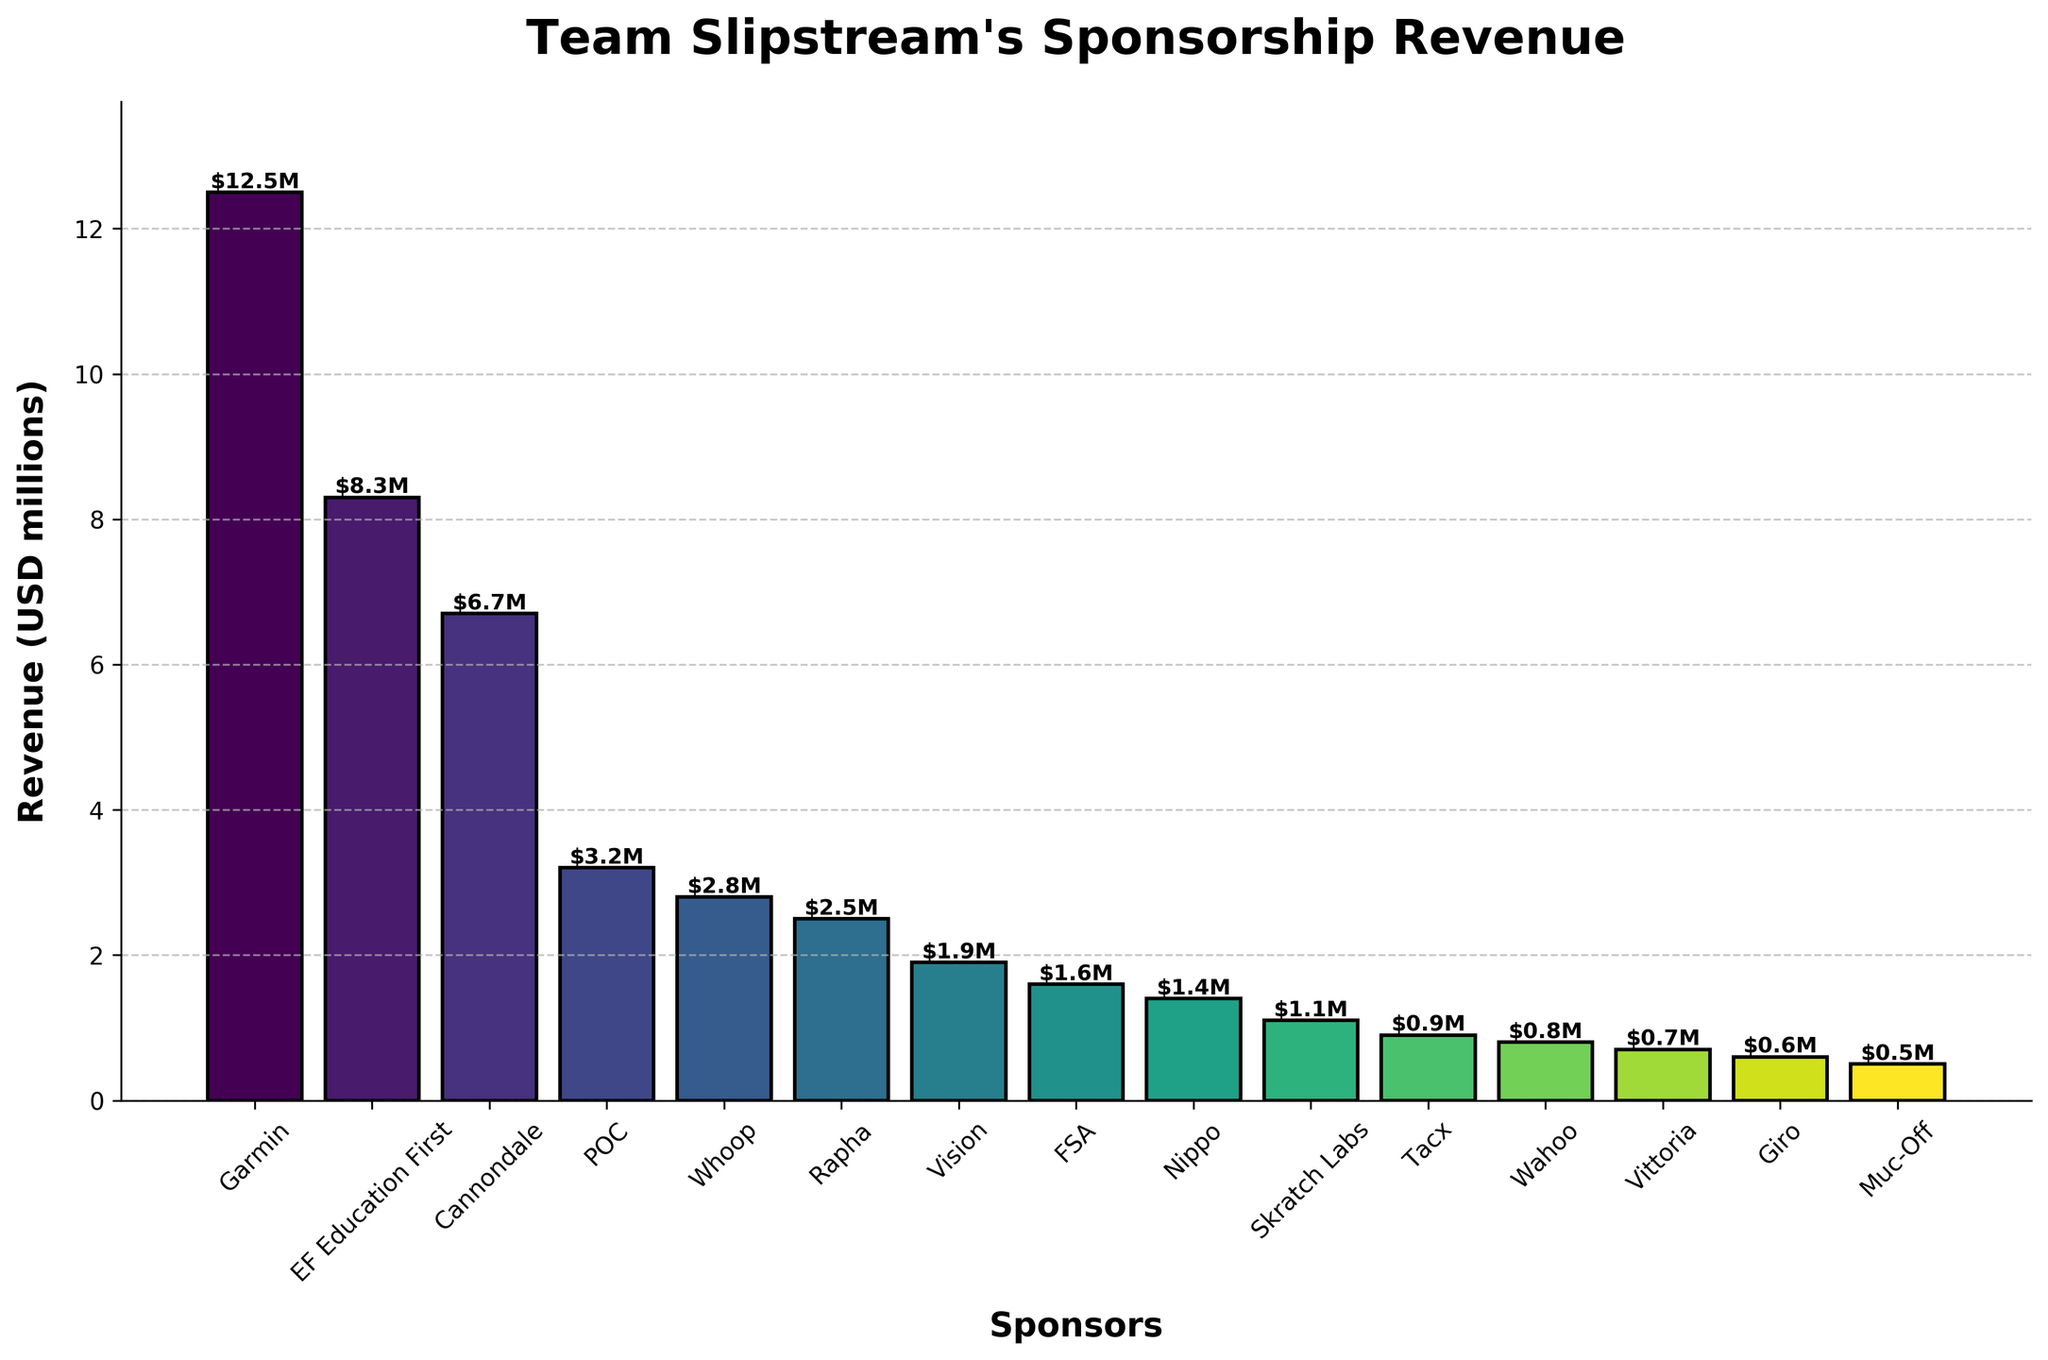Which sponsor contributes the highest revenue? Observing the heights of the bars, the tallest one corresponds to Garmin, indicating it provides the highest sponsorship revenue.
Answer: Garmin What's the total revenue from Garmin and EF Education First combined? Sum the revenues of Garmin (12.5M) and EF Education First (8.3M): 12.5 + 8.3 = 20.8M.
Answer: 20.8M Which sponsor provides the least revenue, and what is the amount? By inspecting the shortest bar, Muc-Off contributes the least with a revenue of 0.5M.
Answer: Muc-Off, 0.5M How much more revenue does Garmin contribute compared to Cannondale? Subtract Cannondale’s revenue (6.7M) from Garmin’s revenue (12.5M): 12.5 - 6.7 = 5.8M.
Answer: 5.8M What is the combined total revenue from sponsors contributing less than 1M each? Sum the revenues of Tacx (0.9M), Wahoo (0.8M), Vittoria (0.7M), Giro (0.6M), and Muc-Off (0.5M): 0.9 + 0.8 + 0.7 + 0.6 + 0.5 = 3.5M.
Answer: 3.5M Which sponsor has a revenue closest to 2M? By checking the bar heights around 2M, Vision has a revenue of 1.9M, which is closest to 2M.
Answer: Vision What is the median revenue value of the sponsors? Sort the revenues and find the middle value. The sorted revenues are: 0.5, 0.6, 0.7, 0.8, 0.9, 1.1, 1.4, 1.6, 1.9, 2.5, 2.8, 3.2, 6.7, 8.3, 12.5. The middle value (median) is 1.6M.
Answer: 1.6M Do more sponsors contribute more than or less than 2M each? Count the sponsors contributing more than 2M (Garmin, EF Education First, Cannondale, POC, Whoop, Rapha) and less than 2M. Six sponsors contribute more than 2M, and nine contribute less than 2M. More sponsors contribute less than 2M.
Answer: Less than What percentage of the total revenue does Garmin contribute? Compute the total revenue: 12.5 + 8.3 + 6.7 + 3.2 + 2.8 + 2.5 + 1.9 + 1.6 + 1.4 + 1.1 + 0.9 + 0.8 + 0.7 + 0.6 + 0.5 = 45.5M. Then, calculate Garmin's percentage: (12.5/45.5) * 100 ≈ 27.5%.
Answer: 27.5% Which sponsors are represented with green and blue-like colors in the chart? Observing the color gradient, sponsors POC (3.2M) and Whoop (2.8M) use blue-like hues, while Rapha (2.5M) uses a green-like hue.
Answer: POC, Whoop, Rapha 